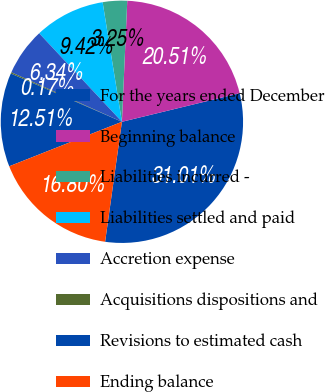Convert chart to OTSL. <chart><loc_0><loc_0><loc_500><loc_500><pie_chart><fcel>For the years ended December<fcel>Beginning balance<fcel>Liabilities incurred -<fcel>Liabilities settled and paid<fcel>Accretion expense<fcel>Acquisitions dispositions and<fcel>Revisions to estimated cash<fcel>Ending balance<nl><fcel>31.01%<fcel>20.51%<fcel>3.25%<fcel>9.42%<fcel>6.34%<fcel>0.17%<fcel>12.51%<fcel>16.8%<nl></chart> 